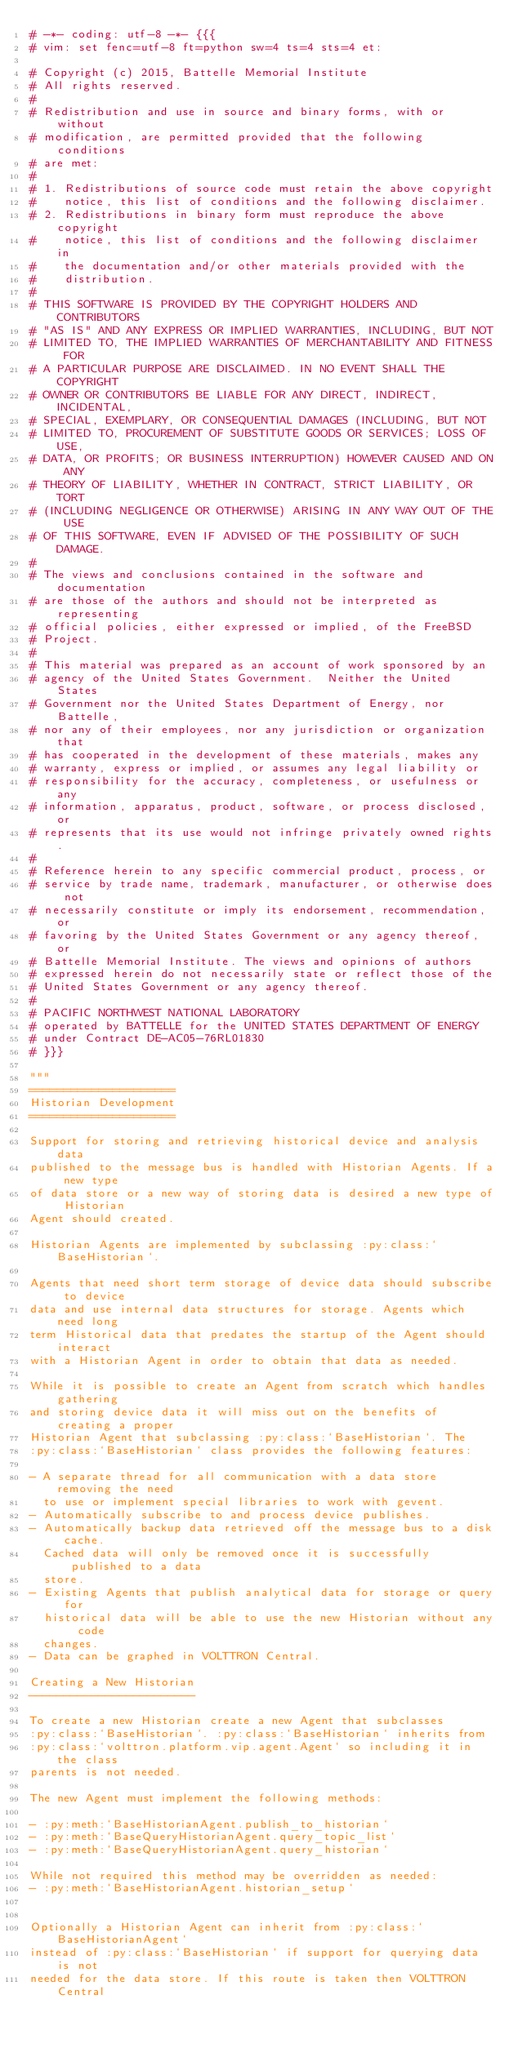<code> <loc_0><loc_0><loc_500><loc_500><_Python_># -*- coding: utf-8 -*- {{{
# vim: set fenc=utf-8 ft=python sw=4 ts=4 sts=4 et:

# Copyright (c) 2015, Battelle Memorial Institute
# All rights reserved.
#
# Redistribution and use in source and binary forms, with or without
# modification, are permitted provided that the following conditions
# are met:
#
# 1. Redistributions of source code must retain the above copyright
#    notice, this list of conditions and the following disclaimer.
# 2. Redistributions in binary form must reproduce the above copyright
#    notice, this list of conditions and the following disclaimer in
#    the documentation and/or other materials provided with the
#    distribution.
#
# THIS SOFTWARE IS PROVIDED BY THE COPYRIGHT HOLDERS AND CONTRIBUTORS
# "AS IS" AND ANY EXPRESS OR IMPLIED WARRANTIES, INCLUDING, BUT NOT
# LIMITED TO, THE IMPLIED WARRANTIES OF MERCHANTABILITY AND FITNESS FOR
# A PARTICULAR PURPOSE ARE DISCLAIMED. IN NO EVENT SHALL THE COPYRIGHT
# OWNER OR CONTRIBUTORS BE LIABLE FOR ANY DIRECT, INDIRECT, INCIDENTAL,
# SPECIAL, EXEMPLARY, OR CONSEQUENTIAL DAMAGES (INCLUDING, BUT NOT
# LIMITED TO, PROCUREMENT OF SUBSTITUTE GOODS OR SERVICES; LOSS OF USE,
# DATA, OR PROFITS; OR BUSINESS INTERRUPTION) HOWEVER CAUSED AND ON ANY
# THEORY OF LIABILITY, WHETHER IN CONTRACT, STRICT LIABILITY, OR TORT
# (INCLUDING NEGLIGENCE OR OTHERWISE) ARISING IN ANY WAY OUT OF THE USE
# OF THIS SOFTWARE, EVEN IF ADVISED OF THE POSSIBILITY OF SUCH DAMAGE.
#
# The views and conclusions contained in the software and documentation
# are those of the authors and should not be interpreted as representing
# official policies, either expressed or implied, of the FreeBSD
# Project.
#
# This material was prepared as an account of work sponsored by an
# agency of the United States Government.  Neither the United States
# Government nor the United States Department of Energy, nor Battelle,
# nor any of their employees, nor any jurisdiction or organization that
# has cooperated in the development of these materials, makes any
# warranty, express or implied, or assumes any legal liability or
# responsibility for the accuracy, completeness, or usefulness or any
# information, apparatus, product, software, or process disclosed, or
# represents that its use would not infringe privately owned rights.
#
# Reference herein to any specific commercial product, process, or
# service by trade name, trademark, manufacturer, or otherwise does not
# necessarily constitute or imply its endorsement, recommendation, or
# favoring by the United States Government or any agency thereof, or
# Battelle Memorial Institute. The views and opinions of authors
# expressed herein do not necessarily state or reflect those of the
# United States Government or any agency thereof.
#
# PACIFIC NORTHWEST NATIONAL LABORATORY
# operated by BATTELLE for the UNITED STATES DEPARTMENT OF ENERGY
# under Contract DE-AC05-76RL01830
# }}}

"""
=====================
Historian Development
=====================

Support for storing and retrieving historical device and analysis data
published to the message bus is handled with Historian Agents. If a new type
of data store or a new way of storing data is desired a new type of Historian
Agent should created.

Historian Agents are implemented by subclassing :py:class:`BaseHistorian`.

Agents that need short term storage of device data should subscribe to device
data and use internal data structures for storage. Agents which need long
term Historical data that predates the startup of the Agent should interact
with a Historian Agent in order to obtain that data as needed.

While it is possible to create an Agent from scratch which handles gathering
and storing device data it will miss out on the benefits of creating a proper
Historian Agent that subclassing :py:class:`BaseHistorian`. The
:py:class:`BaseHistorian` class provides the following features:

- A separate thread for all communication with a data store removing the need
  to use or implement special libraries to work with gevent.
- Automatically subscribe to and process device publishes.
- Automatically backup data retrieved off the message bus to a disk cache.
  Cached data will only be removed once it is successfully published to a data
  store.
- Existing Agents that publish analytical data for storage or query for
  historical data will be able to use the new Historian without any code
  changes.
- Data can be graphed in VOLTTRON Central.

Creating a New Historian
------------------------

To create a new Historian create a new Agent that subclasses
:py:class:`BaseHistorian`. :py:class:`BaseHistorian` inherits from
:py:class:`volttron.platform.vip.agent.Agent` so including it in the class
parents is not needed.

The new Agent must implement the following methods:

- :py:meth:`BaseHistorianAgent.publish_to_historian`
- :py:meth:`BaseQueryHistorianAgent.query_topic_list`
- :py:meth:`BaseQueryHistorianAgent.query_historian`

While not required this method may be overridden as needed:
- :py:meth:`BaseHistorianAgent.historian_setup`


Optionally a Historian Agent can inherit from :py:class:`BaseHistorianAgent`
instead of :py:class:`BaseHistorian` if support for querying data is not
needed for the data store. If this route is taken then VOLTTRON Central</code> 